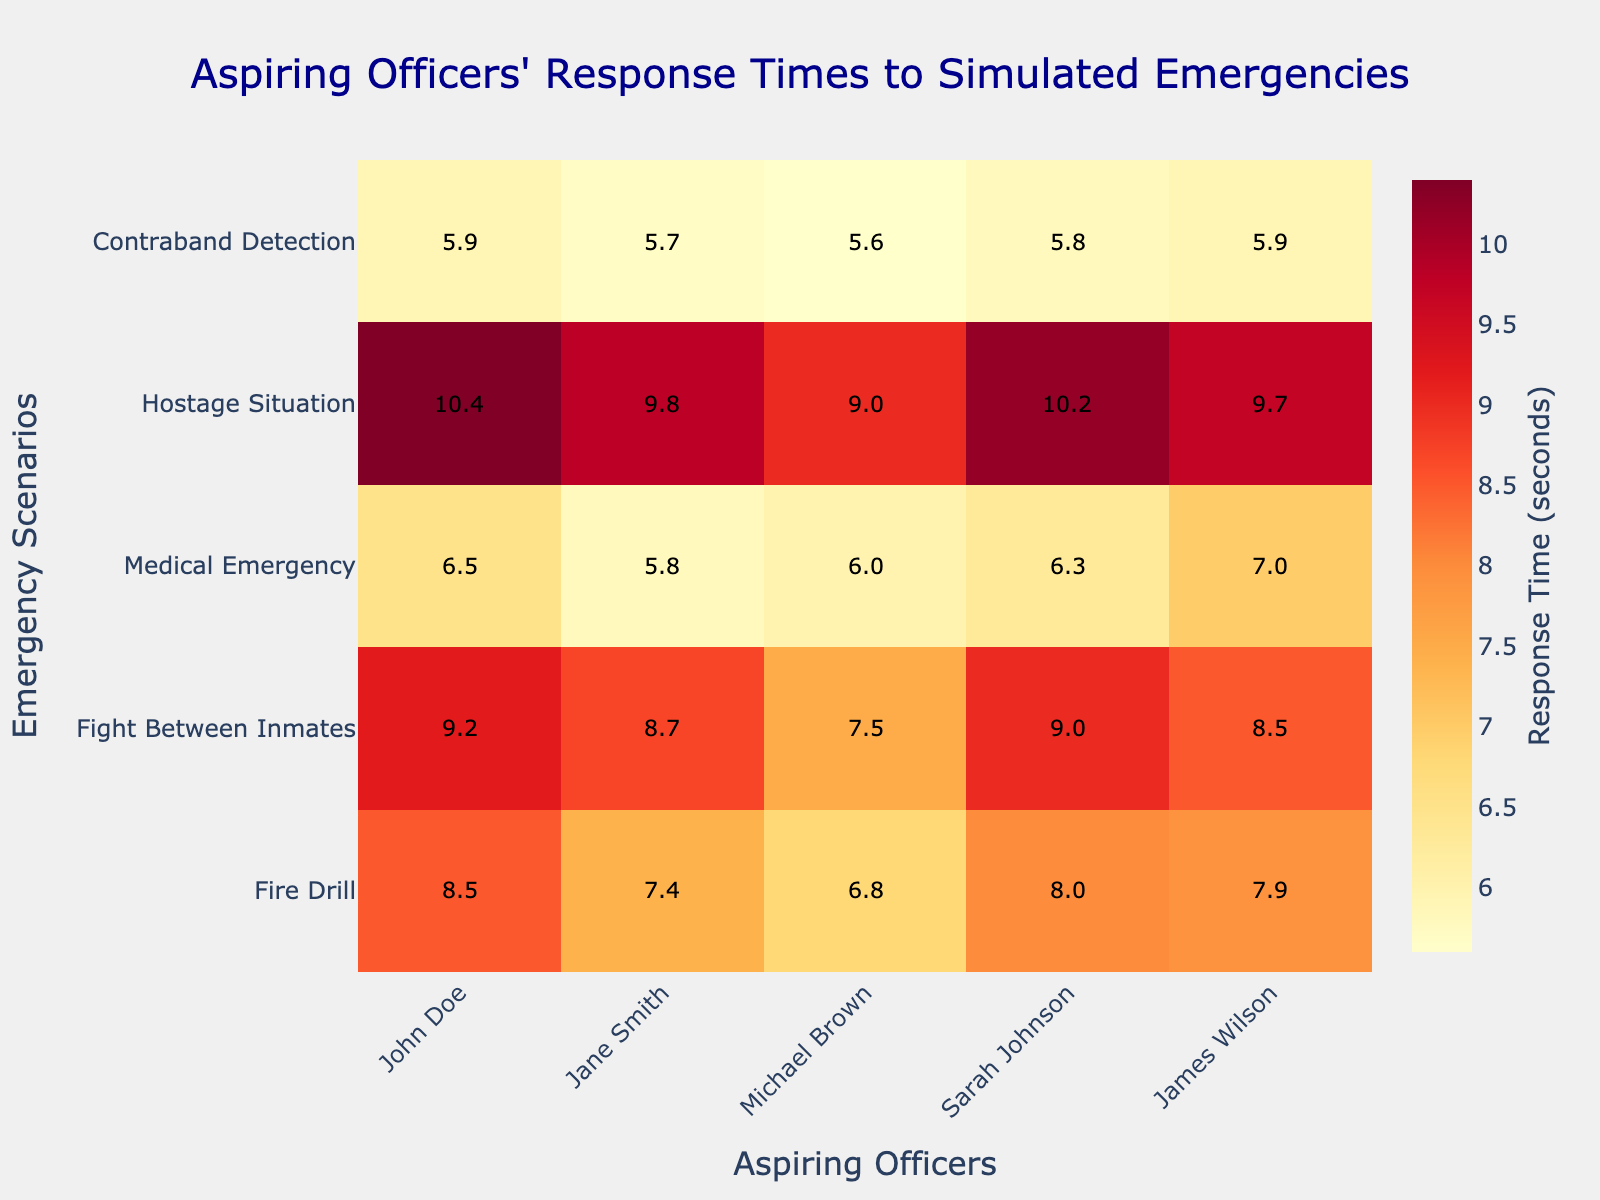What is the title of the heatmap? The title of the heatmap is usually displayed at the top and it helps to quickly understand the context of the data presented.
Answer: Aspiring Officers' Response Times to Simulated Emergencies How many scenarios were evaluated? The number of scenarios can be determined by counting the scenarios listed on the y-axis of the heatmap.
Answer: Five Which aspiring officer had the fastest response time for the Medical Emergency scenario? To determine the fastest response time for the Medical Emergency scenario, locate the Medical Emergency row and find the officer with the smallest number in that row.
Answer: Jane Smith What is the average response time for John Doe across all scenarios? To find the average response time for John Doe, sum his response times from all scenarios and divide by the number of scenarios: (8.5 + 9.2 + 6.5 + 10.4 + 5.9) / 5.
Answer: 8.1 Who responded faster to the Fire Drill, Sarah Johnson or James Wilson? Compare the response times of Sarah Johnson and James Wilson for the Fire Drill scenario. Sarah Johnson's response time is 8.0 seconds, and James Wilson's response time is 7.9 seconds.
Answer: James Wilson Which scenario had the highest average response time across all officers? Calculate the average response time for each scenario by summing the response times of all officers for that scenario and dividing by the number of officers. Compare these averages to find the highest one.
Answer: Hostage Situation How many officers had a response time under 6 seconds for the Contraband Detection scenario? Count the number of officers with response times of less than 6 seconds in the Contraband Detection row.
Answer: All five officers Which officer had the longest response time in any scenario? Identify the highest value in the heatmap to find the longest response time, and note which officer and scenario it corresponds to.
Answer: John Doe for Hostage Situation (10.4 seconds) Compare the response times of Michael Brown and Sarah Johnson for the Fight Between Inmates scenario. Locate the Fight Between Inmates row and compare the response times of Michael Brown and Sarah Johnson. Michael Brown's response time is 7.5 seconds, and Sarah Johnson's response time is 9.0 seconds.
Answer: Michael Brown What is the average response time for all officers during the Fire Drill scenario? Sum the response times for all officers during the Fire Drill scenario and divide by the number of officers: (8.5 + 7.4 + 6.8 + 8.0 + 7.9) / 5.
Answer: 7.72 